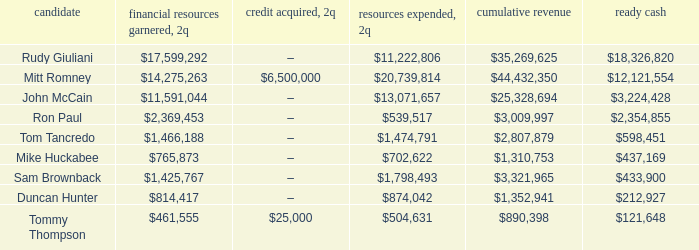Tell me the money raised when 2Q has total receipts of $890,398 $461,555. 